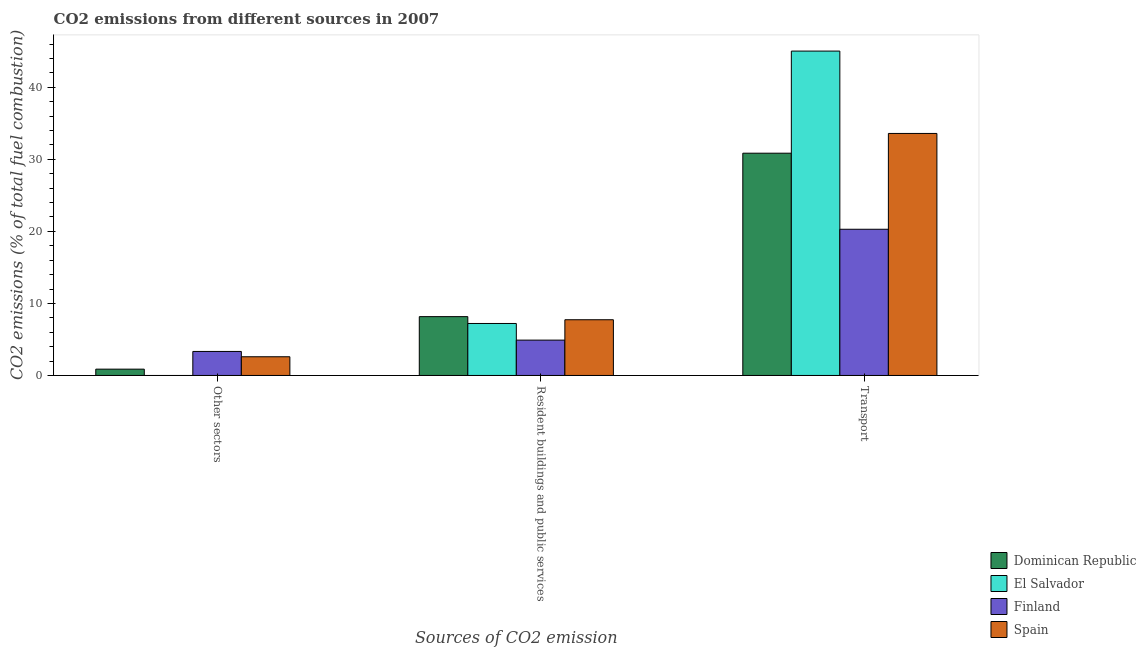How many different coloured bars are there?
Offer a very short reply. 4. How many groups of bars are there?
Your response must be concise. 3. Are the number of bars per tick equal to the number of legend labels?
Keep it short and to the point. No. How many bars are there on the 3rd tick from the left?
Offer a terse response. 4. What is the label of the 1st group of bars from the left?
Ensure brevity in your answer.  Other sectors. What is the percentage of co2 emissions from transport in Dominican Republic?
Provide a short and direct response. 30.85. Across all countries, what is the maximum percentage of co2 emissions from transport?
Provide a short and direct response. 45.02. Across all countries, what is the minimum percentage of co2 emissions from other sectors?
Provide a short and direct response. 0. In which country was the percentage of co2 emissions from resident buildings and public services maximum?
Offer a terse response. Dominican Republic. What is the total percentage of co2 emissions from transport in the graph?
Offer a terse response. 129.76. What is the difference between the percentage of co2 emissions from resident buildings and public services in Spain and that in Finland?
Offer a terse response. 2.83. What is the difference between the percentage of co2 emissions from transport in El Salvador and the percentage of co2 emissions from resident buildings and public services in Dominican Republic?
Your answer should be compact. 36.86. What is the average percentage of co2 emissions from resident buildings and public services per country?
Provide a short and direct response. 7. What is the difference between the percentage of co2 emissions from resident buildings and public services and percentage of co2 emissions from transport in Finland?
Offer a very short reply. -15.39. In how many countries, is the percentage of co2 emissions from other sectors greater than 6 %?
Your answer should be compact. 0. What is the ratio of the percentage of co2 emissions from other sectors in Spain to that in Finland?
Your response must be concise. 0.78. What is the difference between the highest and the second highest percentage of co2 emissions from transport?
Make the answer very short. 11.43. What is the difference between the highest and the lowest percentage of co2 emissions from transport?
Offer a terse response. 24.73. Is it the case that in every country, the sum of the percentage of co2 emissions from other sectors and percentage of co2 emissions from resident buildings and public services is greater than the percentage of co2 emissions from transport?
Make the answer very short. No. Are the values on the major ticks of Y-axis written in scientific E-notation?
Offer a terse response. No. Does the graph contain any zero values?
Make the answer very short. Yes. How many legend labels are there?
Your answer should be compact. 4. How are the legend labels stacked?
Provide a succinct answer. Vertical. What is the title of the graph?
Your response must be concise. CO2 emissions from different sources in 2007. What is the label or title of the X-axis?
Provide a succinct answer. Sources of CO2 emission. What is the label or title of the Y-axis?
Give a very brief answer. CO2 emissions (% of total fuel combustion). What is the CO2 emissions (% of total fuel combustion) of Dominican Republic in Other sectors?
Provide a succinct answer. 0.88. What is the CO2 emissions (% of total fuel combustion) in El Salvador in Other sectors?
Keep it short and to the point. 0. What is the CO2 emissions (% of total fuel combustion) of Finland in Other sectors?
Your answer should be very brief. 3.33. What is the CO2 emissions (% of total fuel combustion) of Spain in Other sectors?
Keep it short and to the point. 2.6. What is the CO2 emissions (% of total fuel combustion) in Dominican Republic in Resident buildings and public services?
Give a very brief answer. 8.16. What is the CO2 emissions (% of total fuel combustion) in El Salvador in Resident buildings and public services?
Offer a very short reply. 7.22. What is the CO2 emissions (% of total fuel combustion) of Finland in Resident buildings and public services?
Give a very brief answer. 4.91. What is the CO2 emissions (% of total fuel combustion) in Spain in Resident buildings and public services?
Ensure brevity in your answer.  7.73. What is the CO2 emissions (% of total fuel combustion) in Dominican Republic in Transport?
Offer a very short reply. 30.85. What is the CO2 emissions (% of total fuel combustion) in El Salvador in Transport?
Provide a succinct answer. 45.02. What is the CO2 emissions (% of total fuel combustion) in Finland in Transport?
Ensure brevity in your answer.  20.29. What is the CO2 emissions (% of total fuel combustion) in Spain in Transport?
Ensure brevity in your answer.  33.59. Across all Sources of CO2 emission, what is the maximum CO2 emissions (% of total fuel combustion) in Dominican Republic?
Offer a very short reply. 30.85. Across all Sources of CO2 emission, what is the maximum CO2 emissions (% of total fuel combustion) of El Salvador?
Offer a very short reply. 45.02. Across all Sources of CO2 emission, what is the maximum CO2 emissions (% of total fuel combustion) of Finland?
Keep it short and to the point. 20.29. Across all Sources of CO2 emission, what is the maximum CO2 emissions (% of total fuel combustion) of Spain?
Your answer should be compact. 33.59. Across all Sources of CO2 emission, what is the minimum CO2 emissions (% of total fuel combustion) of Dominican Republic?
Ensure brevity in your answer.  0.88. Across all Sources of CO2 emission, what is the minimum CO2 emissions (% of total fuel combustion) in El Salvador?
Your response must be concise. 0. Across all Sources of CO2 emission, what is the minimum CO2 emissions (% of total fuel combustion) in Finland?
Your response must be concise. 3.33. Across all Sources of CO2 emission, what is the minimum CO2 emissions (% of total fuel combustion) in Spain?
Your response must be concise. 2.6. What is the total CO2 emissions (% of total fuel combustion) of Dominican Republic in the graph?
Offer a very short reply. 39.89. What is the total CO2 emissions (% of total fuel combustion) in El Salvador in the graph?
Ensure brevity in your answer.  52.24. What is the total CO2 emissions (% of total fuel combustion) in Finland in the graph?
Provide a short and direct response. 28.53. What is the total CO2 emissions (% of total fuel combustion) in Spain in the graph?
Offer a terse response. 43.92. What is the difference between the CO2 emissions (% of total fuel combustion) in Dominican Republic in Other sectors and that in Resident buildings and public services?
Keep it short and to the point. -7.29. What is the difference between the CO2 emissions (% of total fuel combustion) of Finland in Other sectors and that in Resident buildings and public services?
Your answer should be compact. -1.57. What is the difference between the CO2 emissions (% of total fuel combustion) of Spain in Other sectors and that in Resident buildings and public services?
Keep it short and to the point. -5.14. What is the difference between the CO2 emissions (% of total fuel combustion) in Dominican Republic in Other sectors and that in Transport?
Give a very brief answer. -29.97. What is the difference between the CO2 emissions (% of total fuel combustion) of Finland in Other sectors and that in Transport?
Make the answer very short. -16.96. What is the difference between the CO2 emissions (% of total fuel combustion) in Spain in Other sectors and that in Transport?
Provide a succinct answer. -31. What is the difference between the CO2 emissions (% of total fuel combustion) in Dominican Republic in Resident buildings and public services and that in Transport?
Keep it short and to the point. -22.68. What is the difference between the CO2 emissions (% of total fuel combustion) of El Salvador in Resident buildings and public services and that in Transport?
Your answer should be very brief. -37.81. What is the difference between the CO2 emissions (% of total fuel combustion) of Finland in Resident buildings and public services and that in Transport?
Keep it short and to the point. -15.39. What is the difference between the CO2 emissions (% of total fuel combustion) of Spain in Resident buildings and public services and that in Transport?
Your answer should be compact. -25.86. What is the difference between the CO2 emissions (% of total fuel combustion) in Dominican Republic in Other sectors and the CO2 emissions (% of total fuel combustion) in El Salvador in Resident buildings and public services?
Provide a short and direct response. -6.34. What is the difference between the CO2 emissions (% of total fuel combustion) of Dominican Republic in Other sectors and the CO2 emissions (% of total fuel combustion) of Finland in Resident buildings and public services?
Give a very brief answer. -4.03. What is the difference between the CO2 emissions (% of total fuel combustion) in Dominican Republic in Other sectors and the CO2 emissions (% of total fuel combustion) in Spain in Resident buildings and public services?
Give a very brief answer. -6.86. What is the difference between the CO2 emissions (% of total fuel combustion) of Finland in Other sectors and the CO2 emissions (% of total fuel combustion) of Spain in Resident buildings and public services?
Offer a terse response. -4.4. What is the difference between the CO2 emissions (% of total fuel combustion) in Dominican Republic in Other sectors and the CO2 emissions (% of total fuel combustion) in El Salvador in Transport?
Provide a succinct answer. -44.14. What is the difference between the CO2 emissions (% of total fuel combustion) of Dominican Republic in Other sectors and the CO2 emissions (% of total fuel combustion) of Finland in Transport?
Your answer should be very brief. -19.42. What is the difference between the CO2 emissions (% of total fuel combustion) of Dominican Republic in Other sectors and the CO2 emissions (% of total fuel combustion) of Spain in Transport?
Provide a short and direct response. -32.72. What is the difference between the CO2 emissions (% of total fuel combustion) in Finland in Other sectors and the CO2 emissions (% of total fuel combustion) in Spain in Transport?
Give a very brief answer. -30.26. What is the difference between the CO2 emissions (% of total fuel combustion) of Dominican Republic in Resident buildings and public services and the CO2 emissions (% of total fuel combustion) of El Salvador in Transport?
Make the answer very short. -36.86. What is the difference between the CO2 emissions (% of total fuel combustion) of Dominican Republic in Resident buildings and public services and the CO2 emissions (% of total fuel combustion) of Finland in Transport?
Keep it short and to the point. -12.13. What is the difference between the CO2 emissions (% of total fuel combustion) of Dominican Republic in Resident buildings and public services and the CO2 emissions (% of total fuel combustion) of Spain in Transport?
Offer a very short reply. -25.43. What is the difference between the CO2 emissions (% of total fuel combustion) in El Salvador in Resident buildings and public services and the CO2 emissions (% of total fuel combustion) in Finland in Transport?
Make the answer very short. -13.08. What is the difference between the CO2 emissions (% of total fuel combustion) of El Salvador in Resident buildings and public services and the CO2 emissions (% of total fuel combustion) of Spain in Transport?
Offer a terse response. -26.38. What is the difference between the CO2 emissions (% of total fuel combustion) in Finland in Resident buildings and public services and the CO2 emissions (% of total fuel combustion) in Spain in Transport?
Your response must be concise. -28.69. What is the average CO2 emissions (% of total fuel combustion) of Dominican Republic per Sources of CO2 emission?
Give a very brief answer. 13.3. What is the average CO2 emissions (% of total fuel combustion) of El Salvador per Sources of CO2 emission?
Give a very brief answer. 17.41. What is the average CO2 emissions (% of total fuel combustion) in Finland per Sources of CO2 emission?
Ensure brevity in your answer.  9.51. What is the average CO2 emissions (% of total fuel combustion) of Spain per Sources of CO2 emission?
Provide a succinct answer. 14.64. What is the difference between the CO2 emissions (% of total fuel combustion) in Dominican Republic and CO2 emissions (% of total fuel combustion) in Finland in Other sectors?
Offer a terse response. -2.46. What is the difference between the CO2 emissions (% of total fuel combustion) in Dominican Republic and CO2 emissions (% of total fuel combustion) in Spain in Other sectors?
Keep it short and to the point. -1.72. What is the difference between the CO2 emissions (% of total fuel combustion) in Finland and CO2 emissions (% of total fuel combustion) in Spain in Other sectors?
Your response must be concise. 0.74. What is the difference between the CO2 emissions (% of total fuel combustion) of Dominican Republic and CO2 emissions (% of total fuel combustion) of El Salvador in Resident buildings and public services?
Give a very brief answer. 0.95. What is the difference between the CO2 emissions (% of total fuel combustion) in Dominican Republic and CO2 emissions (% of total fuel combustion) in Finland in Resident buildings and public services?
Offer a terse response. 3.26. What is the difference between the CO2 emissions (% of total fuel combustion) of Dominican Republic and CO2 emissions (% of total fuel combustion) of Spain in Resident buildings and public services?
Your answer should be very brief. 0.43. What is the difference between the CO2 emissions (% of total fuel combustion) in El Salvador and CO2 emissions (% of total fuel combustion) in Finland in Resident buildings and public services?
Your response must be concise. 2.31. What is the difference between the CO2 emissions (% of total fuel combustion) of El Salvador and CO2 emissions (% of total fuel combustion) of Spain in Resident buildings and public services?
Keep it short and to the point. -0.52. What is the difference between the CO2 emissions (% of total fuel combustion) of Finland and CO2 emissions (% of total fuel combustion) of Spain in Resident buildings and public services?
Give a very brief answer. -2.83. What is the difference between the CO2 emissions (% of total fuel combustion) in Dominican Republic and CO2 emissions (% of total fuel combustion) in El Salvador in Transport?
Give a very brief answer. -14.17. What is the difference between the CO2 emissions (% of total fuel combustion) in Dominican Republic and CO2 emissions (% of total fuel combustion) in Finland in Transport?
Your response must be concise. 10.56. What is the difference between the CO2 emissions (% of total fuel combustion) of Dominican Republic and CO2 emissions (% of total fuel combustion) of Spain in Transport?
Offer a terse response. -2.74. What is the difference between the CO2 emissions (% of total fuel combustion) of El Salvador and CO2 emissions (% of total fuel combustion) of Finland in Transport?
Offer a very short reply. 24.73. What is the difference between the CO2 emissions (% of total fuel combustion) of El Salvador and CO2 emissions (% of total fuel combustion) of Spain in Transport?
Provide a short and direct response. 11.43. What is the difference between the CO2 emissions (% of total fuel combustion) in Finland and CO2 emissions (% of total fuel combustion) in Spain in Transport?
Your answer should be compact. -13.3. What is the ratio of the CO2 emissions (% of total fuel combustion) of Dominican Republic in Other sectors to that in Resident buildings and public services?
Offer a very short reply. 0.11. What is the ratio of the CO2 emissions (% of total fuel combustion) of Finland in Other sectors to that in Resident buildings and public services?
Your response must be concise. 0.68. What is the ratio of the CO2 emissions (% of total fuel combustion) in Spain in Other sectors to that in Resident buildings and public services?
Offer a terse response. 0.34. What is the ratio of the CO2 emissions (% of total fuel combustion) of Dominican Republic in Other sectors to that in Transport?
Make the answer very short. 0.03. What is the ratio of the CO2 emissions (% of total fuel combustion) in Finland in Other sectors to that in Transport?
Make the answer very short. 0.16. What is the ratio of the CO2 emissions (% of total fuel combustion) in Spain in Other sectors to that in Transport?
Offer a very short reply. 0.08. What is the ratio of the CO2 emissions (% of total fuel combustion) of Dominican Republic in Resident buildings and public services to that in Transport?
Your answer should be very brief. 0.26. What is the ratio of the CO2 emissions (% of total fuel combustion) of El Salvador in Resident buildings and public services to that in Transport?
Provide a succinct answer. 0.16. What is the ratio of the CO2 emissions (% of total fuel combustion) of Finland in Resident buildings and public services to that in Transport?
Offer a terse response. 0.24. What is the ratio of the CO2 emissions (% of total fuel combustion) in Spain in Resident buildings and public services to that in Transport?
Your answer should be very brief. 0.23. What is the difference between the highest and the second highest CO2 emissions (% of total fuel combustion) in Dominican Republic?
Give a very brief answer. 22.68. What is the difference between the highest and the second highest CO2 emissions (% of total fuel combustion) in Finland?
Your answer should be very brief. 15.39. What is the difference between the highest and the second highest CO2 emissions (% of total fuel combustion) in Spain?
Your response must be concise. 25.86. What is the difference between the highest and the lowest CO2 emissions (% of total fuel combustion) of Dominican Republic?
Provide a short and direct response. 29.97. What is the difference between the highest and the lowest CO2 emissions (% of total fuel combustion) of El Salvador?
Make the answer very short. 45.02. What is the difference between the highest and the lowest CO2 emissions (% of total fuel combustion) in Finland?
Your response must be concise. 16.96. What is the difference between the highest and the lowest CO2 emissions (% of total fuel combustion) of Spain?
Give a very brief answer. 31. 